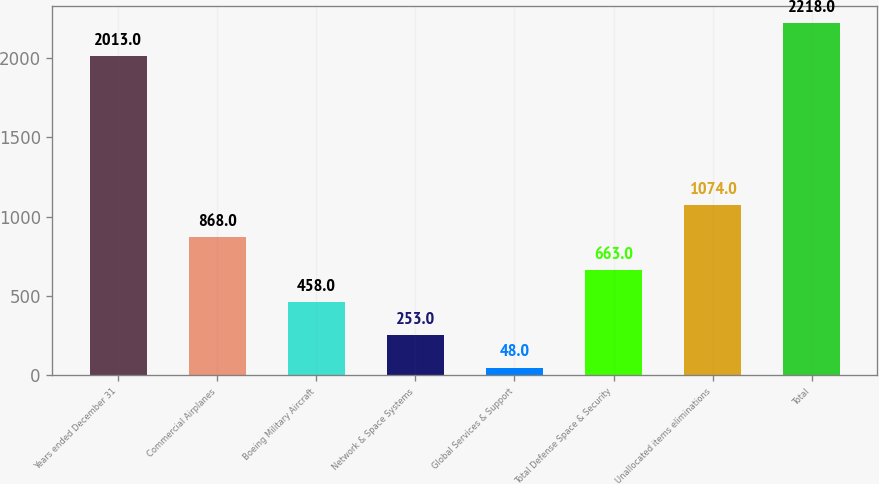Convert chart to OTSL. <chart><loc_0><loc_0><loc_500><loc_500><bar_chart><fcel>Years ended December 31<fcel>Commercial Airplanes<fcel>Boeing Military Aircraft<fcel>Network & Space Systems<fcel>Global Services & Support<fcel>Total Defense Space & Security<fcel>Unallocated items eliminations<fcel>Total<nl><fcel>2013<fcel>868<fcel>458<fcel>253<fcel>48<fcel>663<fcel>1074<fcel>2218<nl></chart> 